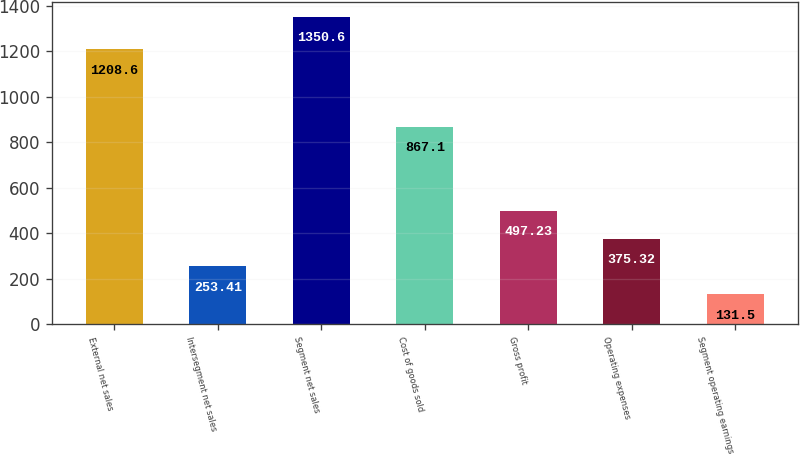Convert chart to OTSL. <chart><loc_0><loc_0><loc_500><loc_500><bar_chart><fcel>External net sales<fcel>Intersegment net sales<fcel>Segment net sales<fcel>Cost of goods sold<fcel>Gross profit<fcel>Operating expenses<fcel>Segment operating earnings<nl><fcel>1208.6<fcel>253.41<fcel>1350.6<fcel>867.1<fcel>497.23<fcel>375.32<fcel>131.5<nl></chart> 